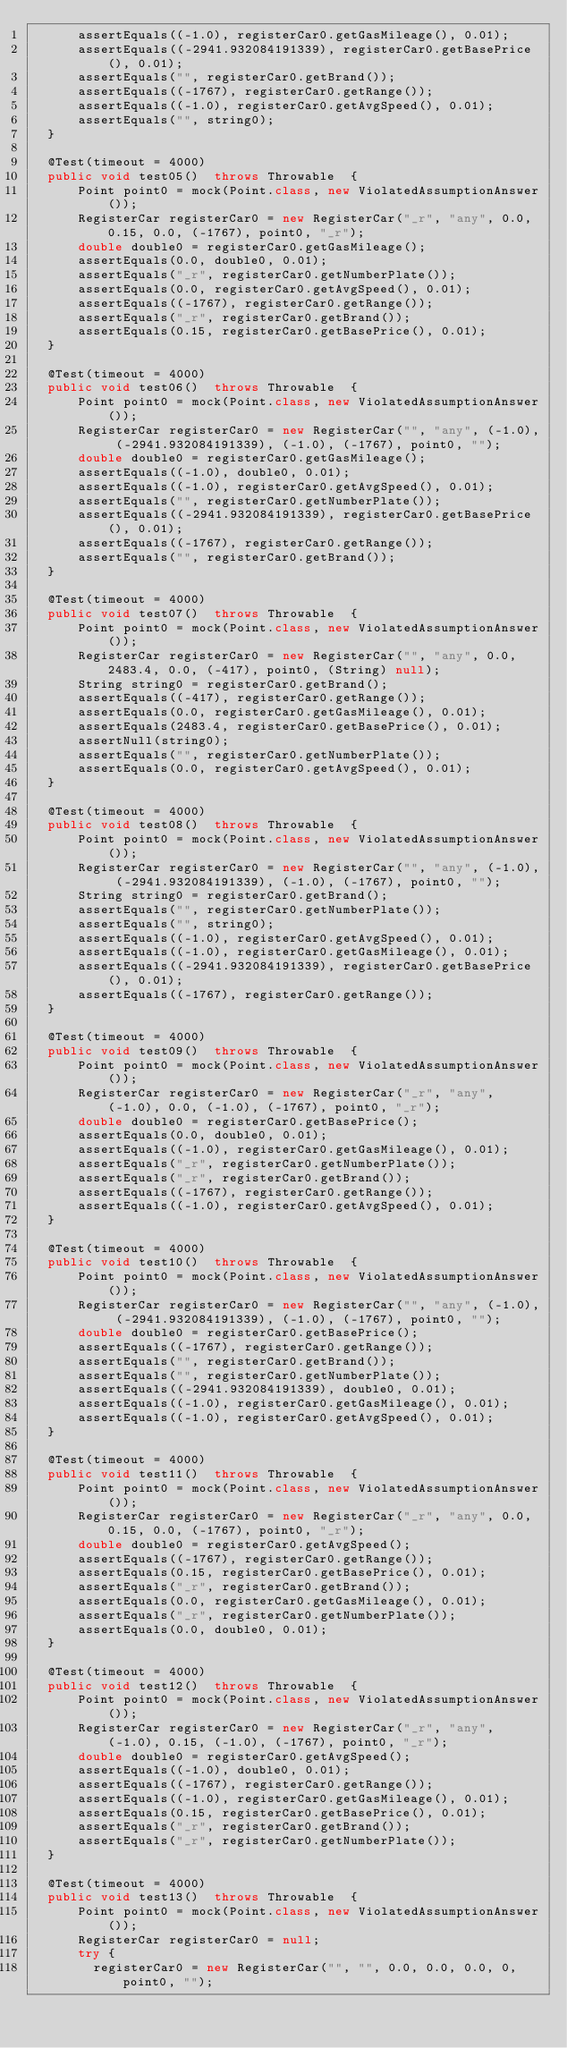<code> <loc_0><loc_0><loc_500><loc_500><_Java_>      assertEquals((-1.0), registerCar0.getGasMileage(), 0.01);
      assertEquals((-2941.932084191339), registerCar0.getBasePrice(), 0.01);
      assertEquals("", registerCar0.getBrand());
      assertEquals((-1767), registerCar0.getRange());
      assertEquals((-1.0), registerCar0.getAvgSpeed(), 0.01);
      assertEquals("", string0);
  }

  @Test(timeout = 4000)
  public void test05()  throws Throwable  {
      Point point0 = mock(Point.class, new ViolatedAssumptionAnswer());
      RegisterCar registerCar0 = new RegisterCar("_r", "any", 0.0, 0.15, 0.0, (-1767), point0, "_r");
      double double0 = registerCar0.getGasMileage();
      assertEquals(0.0, double0, 0.01);
      assertEquals("_r", registerCar0.getNumberPlate());
      assertEquals(0.0, registerCar0.getAvgSpeed(), 0.01);
      assertEquals((-1767), registerCar0.getRange());
      assertEquals("_r", registerCar0.getBrand());
      assertEquals(0.15, registerCar0.getBasePrice(), 0.01);
  }

  @Test(timeout = 4000)
  public void test06()  throws Throwable  {
      Point point0 = mock(Point.class, new ViolatedAssumptionAnswer());
      RegisterCar registerCar0 = new RegisterCar("", "any", (-1.0), (-2941.932084191339), (-1.0), (-1767), point0, "");
      double double0 = registerCar0.getGasMileage();
      assertEquals((-1.0), double0, 0.01);
      assertEquals((-1.0), registerCar0.getAvgSpeed(), 0.01);
      assertEquals("", registerCar0.getNumberPlate());
      assertEquals((-2941.932084191339), registerCar0.getBasePrice(), 0.01);
      assertEquals((-1767), registerCar0.getRange());
      assertEquals("", registerCar0.getBrand());
  }

  @Test(timeout = 4000)
  public void test07()  throws Throwable  {
      Point point0 = mock(Point.class, new ViolatedAssumptionAnswer());
      RegisterCar registerCar0 = new RegisterCar("", "any", 0.0, 2483.4, 0.0, (-417), point0, (String) null);
      String string0 = registerCar0.getBrand();
      assertEquals((-417), registerCar0.getRange());
      assertEquals(0.0, registerCar0.getGasMileage(), 0.01);
      assertEquals(2483.4, registerCar0.getBasePrice(), 0.01);
      assertNull(string0);
      assertEquals("", registerCar0.getNumberPlate());
      assertEquals(0.0, registerCar0.getAvgSpeed(), 0.01);
  }

  @Test(timeout = 4000)
  public void test08()  throws Throwable  {
      Point point0 = mock(Point.class, new ViolatedAssumptionAnswer());
      RegisterCar registerCar0 = new RegisterCar("", "any", (-1.0), (-2941.932084191339), (-1.0), (-1767), point0, "");
      String string0 = registerCar0.getBrand();
      assertEquals("", registerCar0.getNumberPlate());
      assertEquals("", string0);
      assertEquals((-1.0), registerCar0.getAvgSpeed(), 0.01);
      assertEquals((-1.0), registerCar0.getGasMileage(), 0.01);
      assertEquals((-2941.932084191339), registerCar0.getBasePrice(), 0.01);
      assertEquals((-1767), registerCar0.getRange());
  }

  @Test(timeout = 4000)
  public void test09()  throws Throwable  {
      Point point0 = mock(Point.class, new ViolatedAssumptionAnswer());
      RegisterCar registerCar0 = new RegisterCar("_r", "any", (-1.0), 0.0, (-1.0), (-1767), point0, "_r");
      double double0 = registerCar0.getBasePrice();
      assertEquals(0.0, double0, 0.01);
      assertEquals((-1.0), registerCar0.getGasMileage(), 0.01);
      assertEquals("_r", registerCar0.getNumberPlate());
      assertEquals("_r", registerCar0.getBrand());
      assertEquals((-1767), registerCar0.getRange());
      assertEquals((-1.0), registerCar0.getAvgSpeed(), 0.01);
  }

  @Test(timeout = 4000)
  public void test10()  throws Throwable  {
      Point point0 = mock(Point.class, new ViolatedAssumptionAnswer());
      RegisterCar registerCar0 = new RegisterCar("", "any", (-1.0), (-2941.932084191339), (-1.0), (-1767), point0, "");
      double double0 = registerCar0.getBasePrice();
      assertEquals((-1767), registerCar0.getRange());
      assertEquals("", registerCar0.getBrand());
      assertEquals("", registerCar0.getNumberPlate());
      assertEquals((-2941.932084191339), double0, 0.01);
      assertEquals((-1.0), registerCar0.getGasMileage(), 0.01);
      assertEquals((-1.0), registerCar0.getAvgSpeed(), 0.01);
  }

  @Test(timeout = 4000)
  public void test11()  throws Throwable  {
      Point point0 = mock(Point.class, new ViolatedAssumptionAnswer());
      RegisterCar registerCar0 = new RegisterCar("_r", "any", 0.0, 0.15, 0.0, (-1767), point0, "_r");
      double double0 = registerCar0.getAvgSpeed();
      assertEquals((-1767), registerCar0.getRange());
      assertEquals(0.15, registerCar0.getBasePrice(), 0.01);
      assertEquals("_r", registerCar0.getBrand());
      assertEquals(0.0, registerCar0.getGasMileage(), 0.01);
      assertEquals("_r", registerCar0.getNumberPlate());
      assertEquals(0.0, double0, 0.01);
  }

  @Test(timeout = 4000)
  public void test12()  throws Throwable  {
      Point point0 = mock(Point.class, new ViolatedAssumptionAnswer());
      RegisterCar registerCar0 = new RegisterCar("_r", "any", (-1.0), 0.15, (-1.0), (-1767), point0, "_r");
      double double0 = registerCar0.getAvgSpeed();
      assertEquals((-1.0), double0, 0.01);
      assertEquals((-1767), registerCar0.getRange());
      assertEquals((-1.0), registerCar0.getGasMileage(), 0.01);
      assertEquals(0.15, registerCar0.getBasePrice(), 0.01);
      assertEquals("_r", registerCar0.getBrand());
      assertEquals("_r", registerCar0.getNumberPlate());
  }

  @Test(timeout = 4000)
  public void test13()  throws Throwable  {
      Point point0 = mock(Point.class, new ViolatedAssumptionAnswer());
      RegisterCar registerCar0 = null;
      try {
        registerCar0 = new RegisterCar("", "", 0.0, 0.0, 0.0, 0, point0, "");</code> 